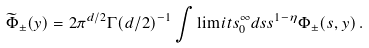<formula> <loc_0><loc_0><loc_500><loc_500>\widetilde { \Phi } _ { \pm } ( y ) = 2 \pi ^ { d / 2 } \Gamma ( d / 2 ) ^ { - 1 } \int \lim i t s _ { 0 } ^ { \infty } d s s ^ { 1 - \eta } \Phi _ { \pm } ( s , y ) \, .</formula> 